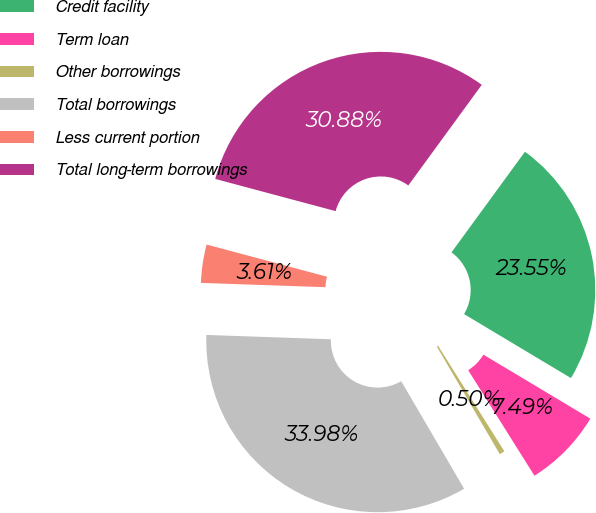Convert chart. <chart><loc_0><loc_0><loc_500><loc_500><pie_chart><fcel>Credit facility<fcel>Term loan<fcel>Other borrowings<fcel>Total borrowings<fcel>Less current portion<fcel>Total long-term borrowings<nl><fcel>23.55%<fcel>7.49%<fcel>0.5%<fcel>33.98%<fcel>3.61%<fcel>30.88%<nl></chart> 